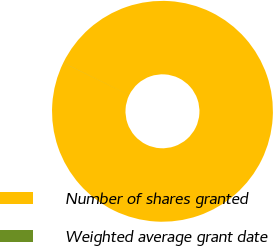<chart> <loc_0><loc_0><loc_500><loc_500><pie_chart><fcel>Number of shares granted<fcel>Weighted average grant date<nl><fcel>99.99%<fcel>0.01%<nl></chart> 